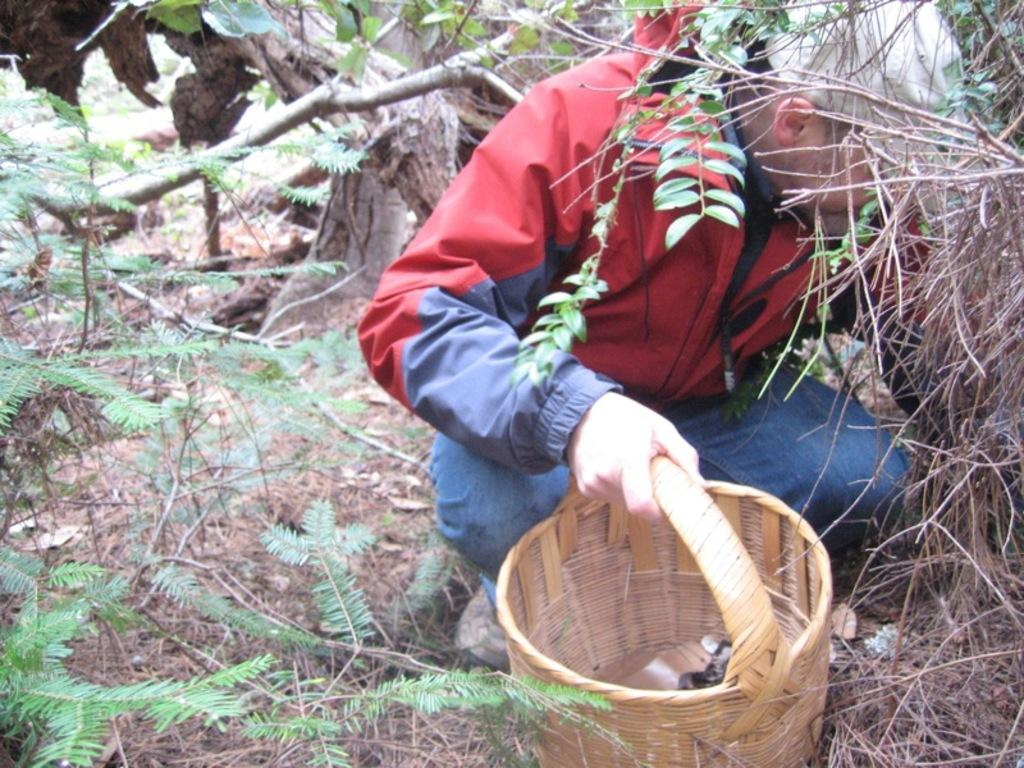What is the person in the image doing? The person is sitting in a squat position. What is the person holding in the image? The person is holding a basket. What can be seen in the background or surrounding the person? Leaves are present in the image. What type of feather can be seen on the person's head in the image? There is no feather present on the person's head in the image. What is the relation between the person and the baby in the image? There is no baby present in the image, so it is not possible to determine the relation between the person and a baby. 